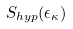Convert formula to latex. <formula><loc_0><loc_0><loc_500><loc_500>S _ { h y p } ( \epsilon _ { \kappa } )</formula> 